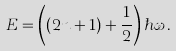<formula> <loc_0><loc_0><loc_500><loc_500>E = \left ( ( 2 n + 1 ) + \frac { 1 } { 2 } \right ) \hbar { \omega } \, .</formula> 